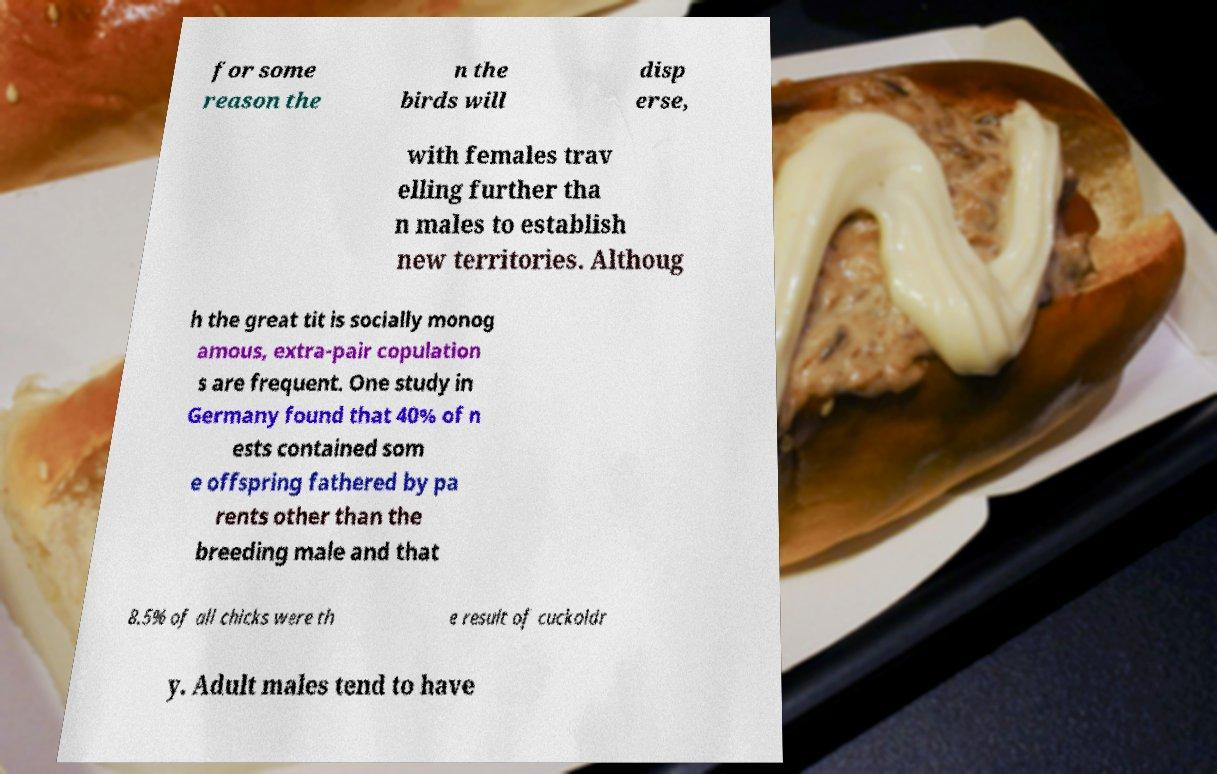Please read and relay the text visible in this image. What does it say? for some reason the n the birds will disp erse, with females trav elling further tha n males to establish new territories. Althoug h the great tit is socially monog amous, extra-pair copulation s are frequent. One study in Germany found that 40% of n ests contained som e offspring fathered by pa rents other than the breeding male and that 8.5% of all chicks were th e result of cuckoldr y. Adult males tend to have 